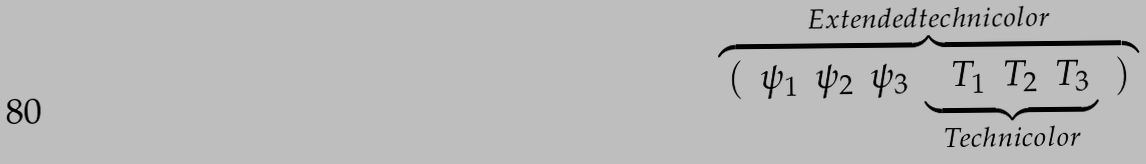Convert formula to latex. <formula><loc_0><loc_0><loc_500><loc_500>\overbrace { \begin{array} { c c c c c c } ( & \psi _ { 1 } & \psi _ { 2 } & \psi _ { 3 } & \underbrace { \begin{array} { c c c c } & T _ { 1 } & T _ { 2 } & T _ { 3 } \end{array} } _ { T e c h n i c o l o r } & ) \end{array} } ^ { E x t e n d e d t e c h n i c o l o r }</formula> 